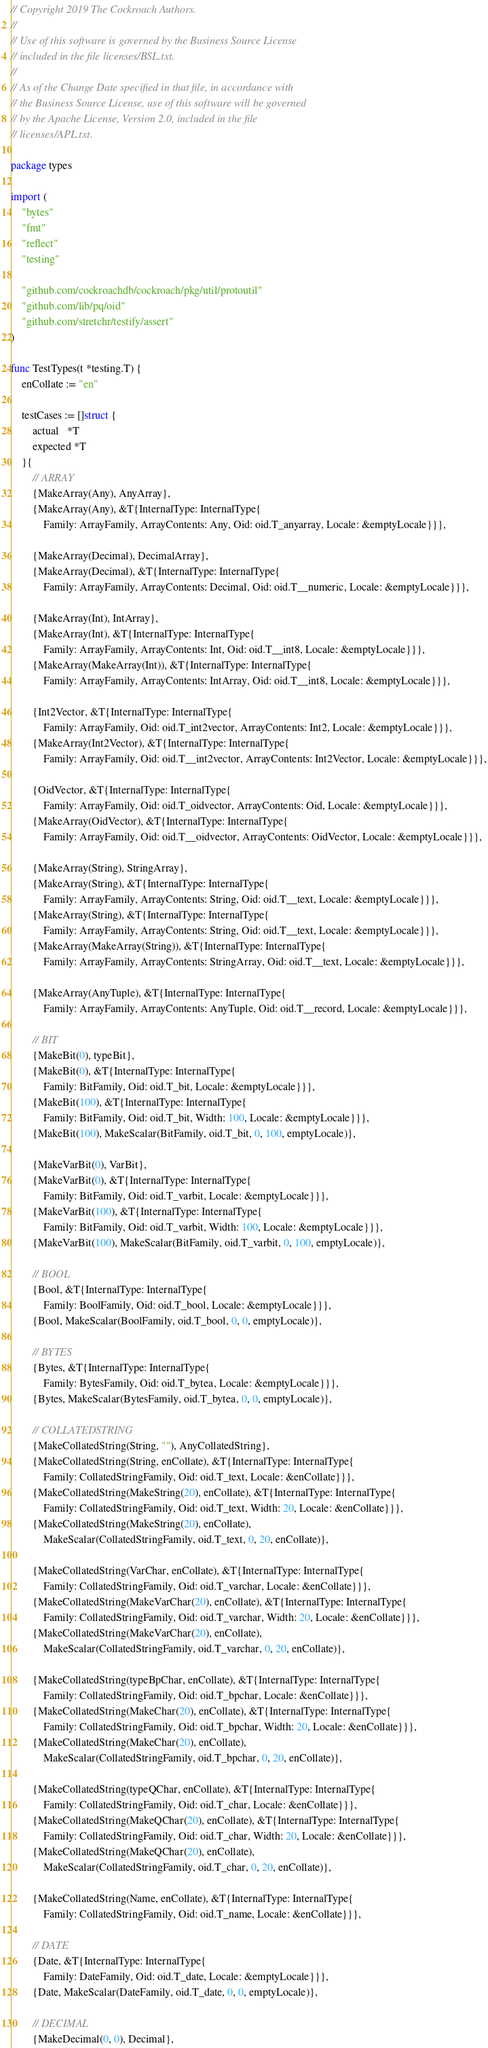Convert code to text. <code><loc_0><loc_0><loc_500><loc_500><_Go_>// Copyright 2019 The Cockroach Authors.
//
// Use of this software is governed by the Business Source License
// included in the file licenses/BSL.txt.
//
// As of the Change Date specified in that file, in accordance with
// the Business Source License, use of this software will be governed
// by the Apache License, Version 2.0, included in the file
// licenses/APL.txt.

package types

import (
	"bytes"
	"fmt"
	"reflect"
	"testing"

	"github.com/cockroachdb/cockroach/pkg/util/protoutil"
	"github.com/lib/pq/oid"
	"github.com/stretchr/testify/assert"
)

func TestTypes(t *testing.T) {
	enCollate := "en"

	testCases := []struct {
		actual   *T
		expected *T
	}{
		// ARRAY
		{MakeArray(Any), AnyArray},
		{MakeArray(Any), &T{InternalType: InternalType{
			Family: ArrayFamily, ArrayContents: Any, Oid: oid.T_anyarray, Locale: &emptyLocale}}},

		{MakeArray(Decimal), DecimalArray},
		{MakeArray(Decimal), &T{InternalType: InternalType{
			Family: ArrayFamily, ArrayContents: Decimal, Oid: oid.T__numeric, Locale: &emptyLocale}}},

		{MakeArray(Int), IntArray},
		{MakeArray(Int), &T{InternalType: InternalType{
			Family: ArrayFamily, ArrayContents: Int, Oid: oid.T__int8, Locale: &emptyLocale}}},
		{MakeArray(MakeArray(Int)), &T{InternalType: InternalType{
			Family: ArrayFamily, ArrayContents: IntArray, Oid: oid.T__int8, Locale: &emptyLocale}}},

		{Int2Vector, &T{InternalType: InternalType{
			Family: ArrayFamily, Oid: oid.T_int2vector, ArrayContents: Int2, Locale: &emptyLocale}}},
		{MakeArray(Int2Vector), &T{InternalType: InternalType{
			Family: ArrayFamily, Oid: oid.T__int2vector, ArrayContents: Int2Vector, Locale: &emptyLocale}}},

		{OidVector, &T{InternalType: InternalType{
			Family: ArrayFamily, Oid: oid.T_oidvector, ArrayContents: Oid, Locale: &emptyLocale}}},
		{MakeArray(OidVector), &T{InternalType: InternalType{
			Family: ArrayFamily, Oid: oid.T__oidvector, ArrayContents: OidVector, Locale: &emptyLocale}}},

		{MakeArray(String), StringArray},
		{MakeArray(String), &T{InternalType: InternalType{
			Family: ArrayFamily, ArrayContents: String, Oid: oid.T__text, Locale: &emptyLocale}}},
		{MakeArray(String), &T{InternalType: InternalType{
			Family: ArrayFamily, ArrayContents: String, Oid: oid.T__text, Locale: &emptyLocale}}},
		{MakeArray(MakeArray(String)), &T{InternalType: InternalType{
			Family: ArrayFamily, ArrayContents: StringArray, Oid: oid.T__text, Locale: &emptyLocale}}},

		{MakeArray(AnyTuple), &T{InternalType: InternalType{
			Family: ArrayFamily, ArrayContents: AnyTuple, Oid: oid.T__record, Locale: &emptyLocale}}},

		// BIT
		{MakeBit(0), typeBit},
		{MakeBit(0), &T{InternalType: InternalType{
			Family: BitFamily, Oid: oid.T_bit, Locale: &emptyLocale}}},
		{MakeBit(100), &T{InternalType: InternalType{
			Family: BitFamily, Oid: oid.T_bit, Width: 100, Locale: &emptyLocale}}},
		{MakeBit(100), MakeScalar(BitFamily, oid.T_bit, 0, 100, emptyLocale)},

		{MakeVarBit(0), VarBit},
		{MakeVarBit(0), &T{InternalType: InternalType{
			Family: BitFamily, Oid: oid.T_varbit, Locale: &emptyLocale}}},
		{MakeVarBit(100), &T{InternalType: InternalType{
			Family: BitFamily, Oid: oid.T_varbit, Width: 100, Locale: &emptyLocale}}},
		{MakeVarBit(100), MakeScalar(BitFamily, oid.T_varbit, 0, 100, emptyLocale)},

		// BOOL
		{Bool, &T{InternalType: InternalType{
			Family: BoolFamily, Oid: oid.T_bool, Locale: &emptyLocale}}},
		{Bool, MakeScalar(BoolFamily, oid.T_bool, 0, 0, emptyLocale)},

		// BYTES
		{Bytes, &T{InternalType: InternalType{
			Family: BytesFamily, Oid: oid.T_bytea, Locale: &emptyLocale}}},
		{Bytes, MakeScalar(BytesFamily, oid.T_bytea, 0, 0, emptyLocale)},

		// COLLATEDSTRING
		{MakeCollatedString(String, ""), AnyCollatedString},
		{MakeCollatedString(String, enCollate), &T{InternalType: InternalType{
			Family: CollatedStringFamily, Oid: oid.T_text, Locale: &enCollate}}},
		{MakeCollatedString(MakeString(20), enCollate), &T{InternalType: InternalType{
			Family: CollatedStringFamily, Oid: oid.T_text, Width: 20, Locale: &enCollate}}},
		{MakeCollatedString(MakeString(20), enCollate),
			MakeScalar(CollatedStringFamily, oid.T_text, 0, 20, enCollate)},

		{MakeCollatedString(VarChar, enCollate), &T{InternalType: InternalType{
			Family: CollatedStringFamily, Oid: oid.T_varchar, Locale: &enCollate}}},
		{MakeCollatedString(MakeVarChar(20), enCollate), &T{InternalType: InternalType{
			Family: CollatedStringFamily, Oid: oid.T_varchar, Width: 20, Locale: &enCollate}}},
		{MakeCollatedString(MakeVarChar(20), enCollate),
			MakeScalar(CollatedStringFamily, oid.T_varchar, 0, 20, enCollate)},

		{MakeCollatedString(typeBpChar, enCollate), &T{InternalType: InternalType{
			Family: CollatedStringFamily, Oid: oid.T_bpchar, Locale: &enCollate}}},
		{MakeCollatedString(MakeChar(20), enCollate), &T{InternalType: InternalType{
			Family: CollatedStringFamily, Oid: oid.T_bpchar, Width: 20, Locale: &enCollate}}},
		{MakeCollatedString(MakeChar(20), enCollate),
			MakeScalar(CollatedStringFamily, oid.T_bpchar, 0, 20, enCollate)},

		{MakeCollatedString(typeQChar, enCollate), &T{InternalType: InternalType{
			Family: CollatedStringFamily, Oid: oid.T_char, Locale: &enCollate}}},
		{MakeCollatedString(MakeQChar(20), enCollate), &T{InternalType: InternalType{
			Family: CollatedStringFamily, Oid: oid.T_char, Width: 20, Locale: &enCollate}}},
		{MakeCollatedString(MakeQChar(20), enCollate),
			MakeScalar(CollatedStringFamily, oid.T_char, 0, 20, enCollate)},

		{MakeCollatedString(Name, enCollate), &T{InternalType: InternalType{
			Family: CollatedStringFamily, Oid: oid.T_name, Locale: &enCollate}}},

		// DATE
		{Date, &T{InternalType: InternalType{
			Family: DateFamily, Oid: oid.T_date, Locale: &emptyLocale}}},
		{Date, MakeScalar(DateFamily, oid.T_date, 0, 0, emptyLocale)},

		// DECIMAL
		{MakeDecimal(0, 0), Decimal},</code> 